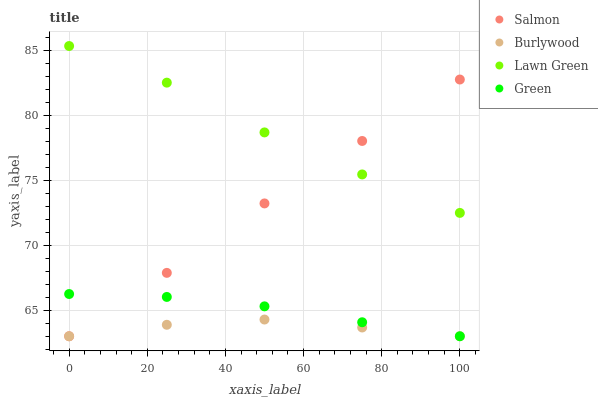Does Burlywood have the minimum area under the curve?
Answer yes or no. Yes. Does Lawn Green have the maximum area under the curve?
Answer yes or no. Yes. Does Green have the minimum area under the curve?
Answer yes or no. No. Does Green have the maximum area under the curve?
Answer yes or no. No. Is Salmon the smoothest?
Answer yes or no. Yes. Is Lawn Green the roughest?
Answer yes or no. Yes. Is Green the smoothest?
Answer yes or no. No. Is Green the roughest?
Answer yes or no. No. Does Burlywood have the lowest value?
Answer yes or no. Yes. Does Lawn Green have the lowest value?
Answer yes or no. No. Does Lawn Green have the highest value?
Answer yes or no. Yes. Does Green have the highest value?
Answer yes or no. No. Is Burlywood less than Lawn Green?
Answer yes or no. Yes. Is Lawn Green greater than Burlywood?
Answer yes or no. Yes. Does Burlywood intersect Salmon?
Answer yes or no. Yes. Is Burlywood less than Salmon?
Answer yes or no. No. Is Burlywood greater than Salmon?
Answer yes or no. No. Does Burlywood intersect Lawn Green?
Answer yes or no. No. 